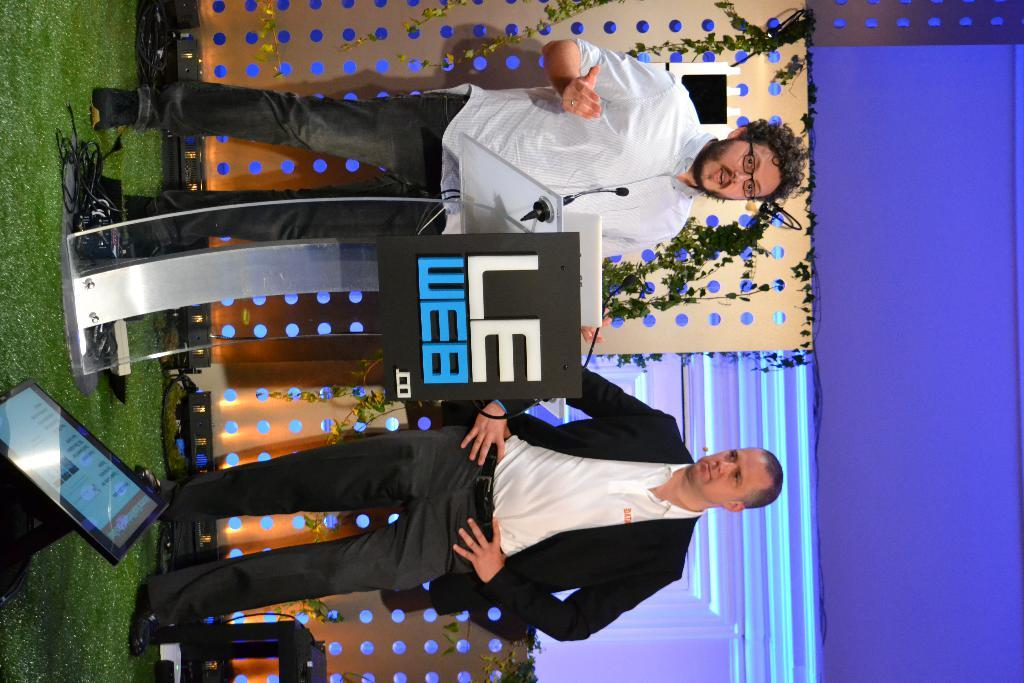What is the man near in the image? The man is standing near a podium in the image. What is the man doing near the podium? The man is speaking. Can you describe the other man in the image? There is another man at the bottom of the image. What is located on the left side of the image? There is an electronic display on the left side of the image. What type of drug is being sold at the bottom of the image? There is no reference to any drug in the image; it features a man standing near a podium and another man at the bottom of the image, along with an electronic display. 